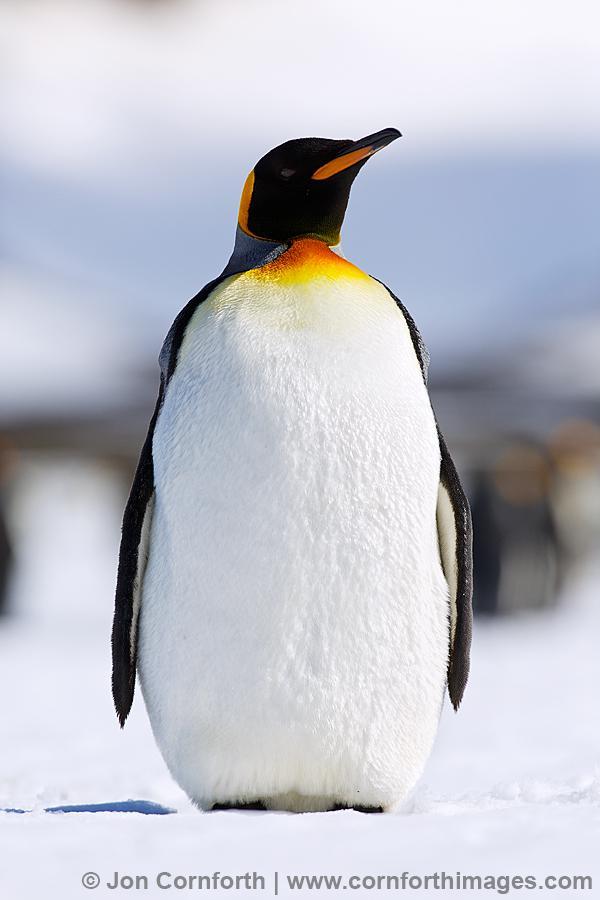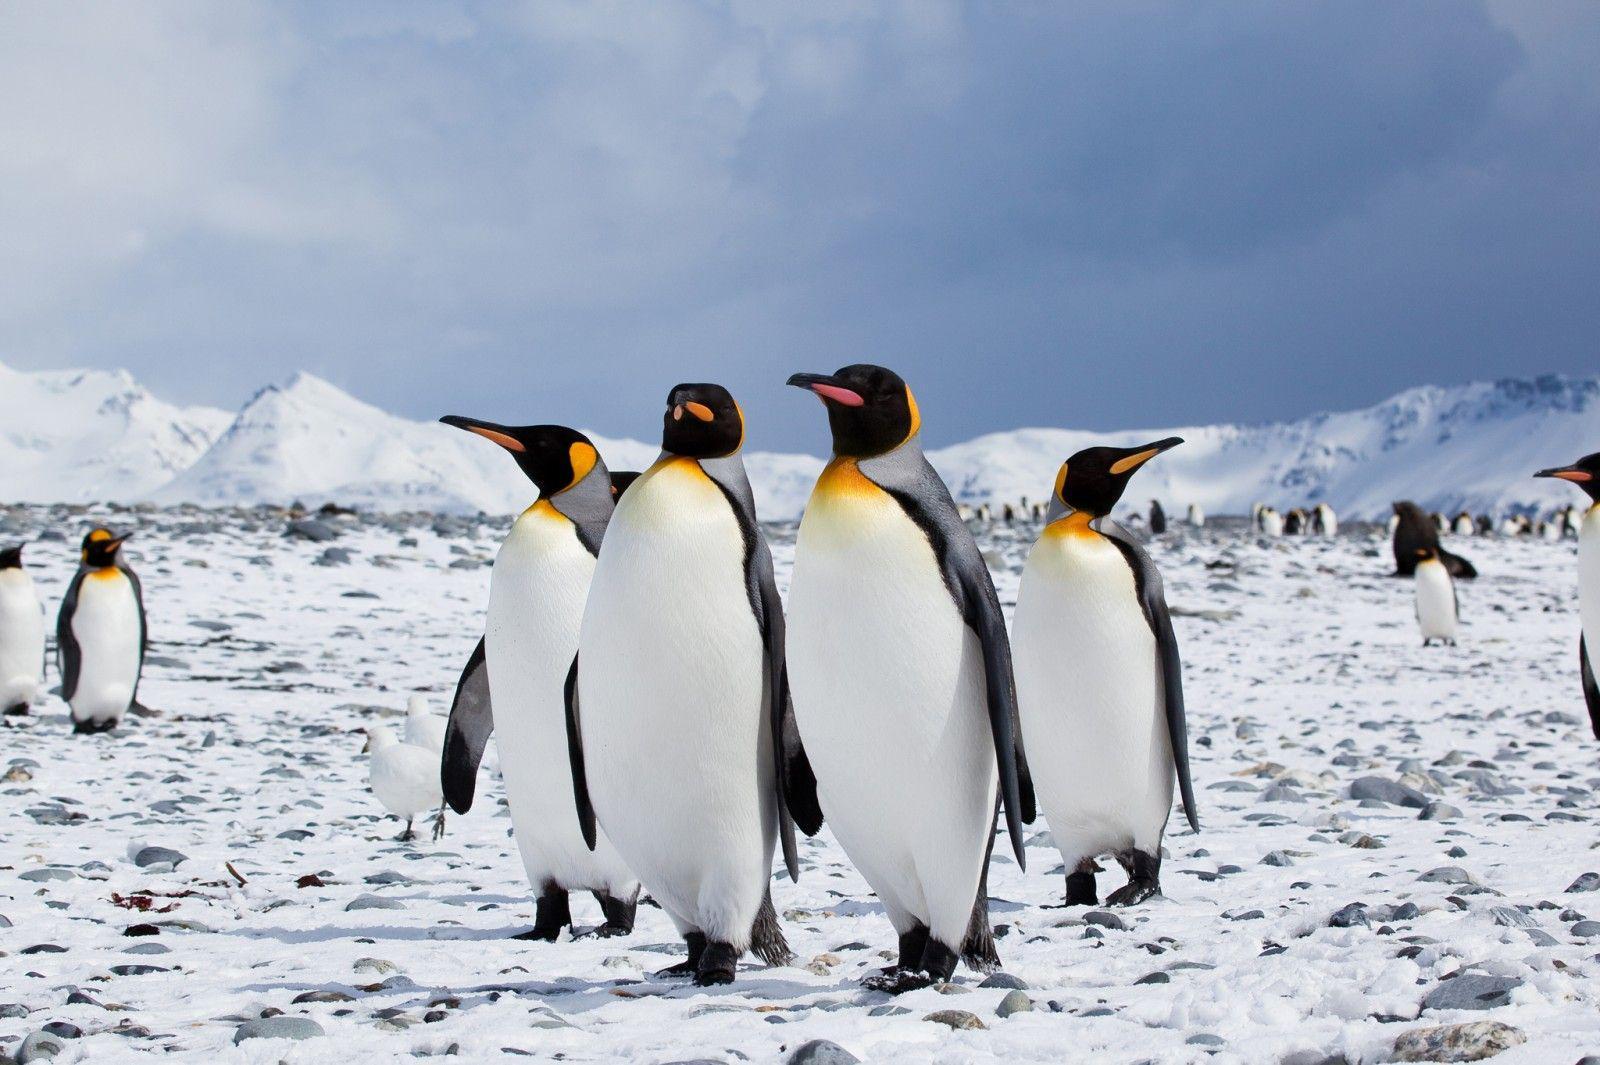The first image is the image on the left, the second image is the image on the right. Analyze the images presented: Is the assertion "A single black and white penguin with yellow markings stands alone in the image on the left." valid? Answer yes or no. Yes. The first image is the image on the left, the second image is the image on the right. For the images shown, is this caption "There is no more than one penguin in the left image." true? Answer yes or no. Yes. 